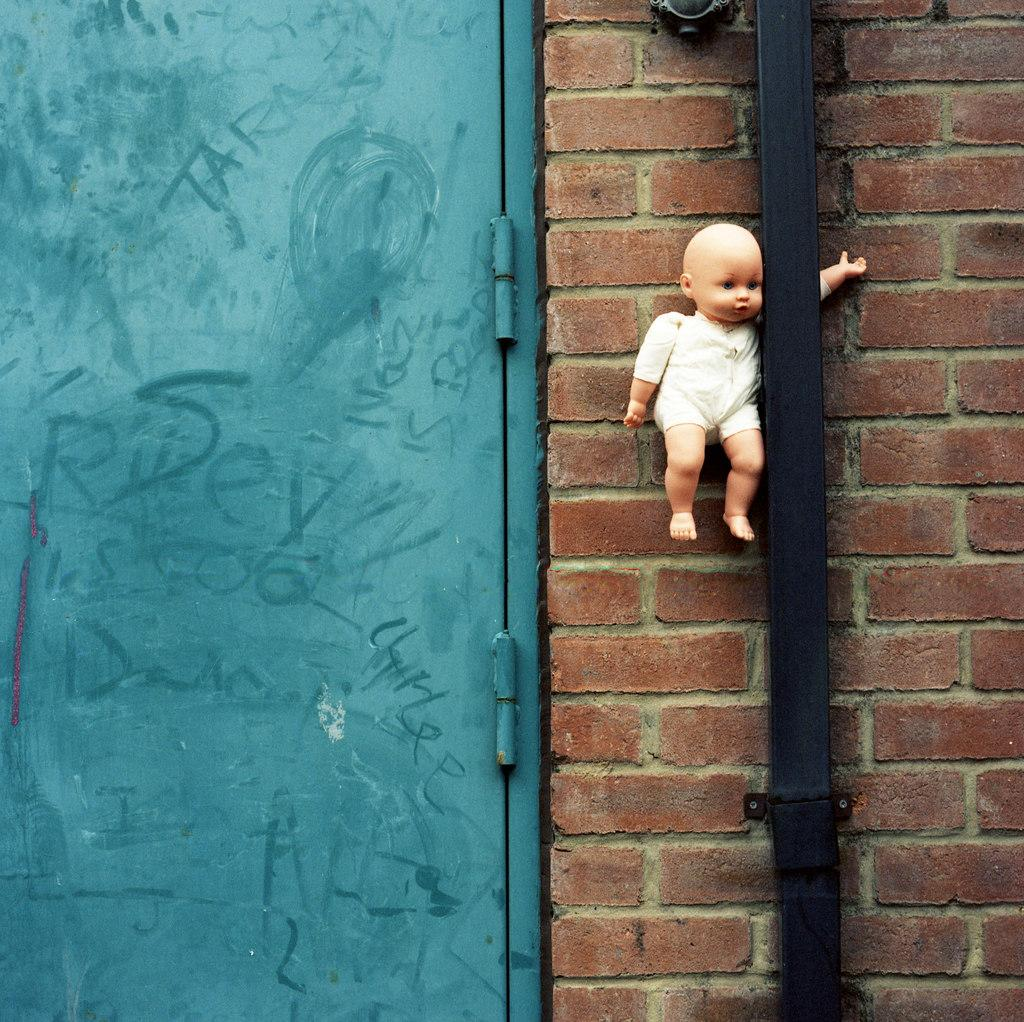What type of toy is present in the image? There is a toy hand in the image. Where is the toy hand positioned in relation to other objects? The toy hand is between a wall and a rod. What can be seen on the left side of the image? There is a door on the left side of the image. What type of ring is the actor wearing on their finger in the image? There is no actor or ring present in the image; it features a toy hand between a wall and a rod, with a door on the left side. 